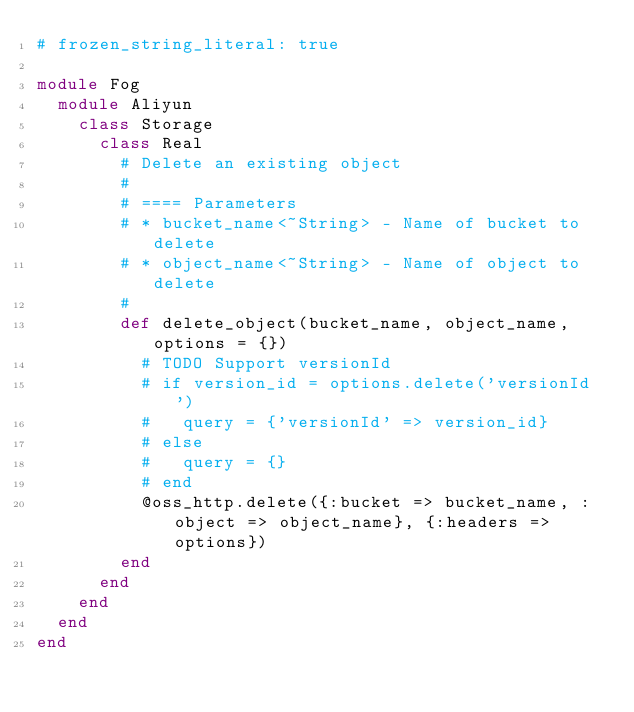Convert code to text. <code><loc_0><loc_0><loc_500><loc_500><_Ruby_># frozen_string_literal: true

module Fog
  module Aliyun
    class Storage
      class Real
        # Delete an existing object
        #
        # ==== Parameters
        # * bucket_name<~String> - Name of bucket to delete
        # * object_name<~String> - Name of object to delete
        #
        def delete_object(bucket_name, object_name, options = {})
          # TODO Support versionId
          # if version_id = options.delete('versionId')
          #   query = {'versionId' => version_id}
          # else
          #   query = {}
          # end
          @oss_http.delete({:bucket => bucket_name, :object => object_name}, {:headers => options})
        end
      end
    end
  end
end
</code> 